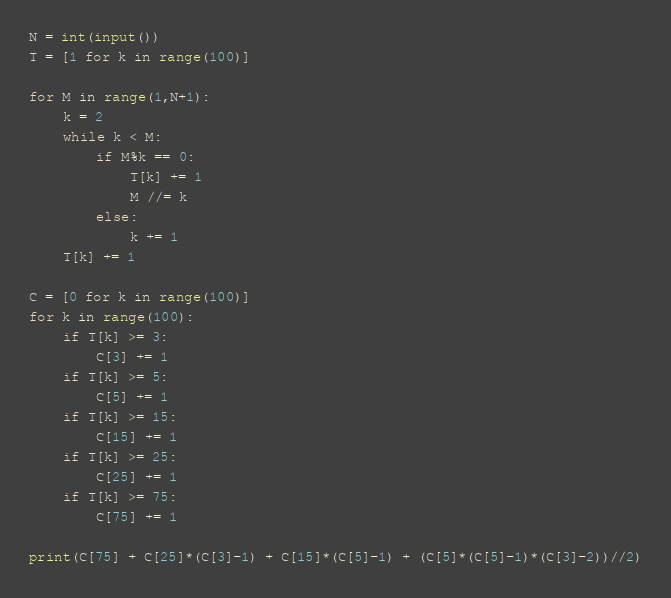<code> <loc_0><loc_0><loc_500><loc_500><_Python_>N = int(input())
T = [1 for k in range(100)]

for M in range(1,N+1):
    k = 2
    while k < M:
        if M%k == 0:
            T[k] += 1
            M //= k
        else:
            k += 1
    T[k] += 1

C = [0 for k in range(100)]
for k in range(100):
    if T[k] >= 3:
        C[3] += 1
    if T[k] >= 5:
        C[5] += 1
    if T[k] >= 15:
        C[15] += 1
    if T[k] >= 25:
        C[25] += 1
    if T[k] >= 75:
        C[75] += 1

print(C[75] + C[25]*(C[3]-1) + C[15]*(C[5]-1) + (C[5]*(C[5]-1)*(C[3]-2))//2)
</code> 